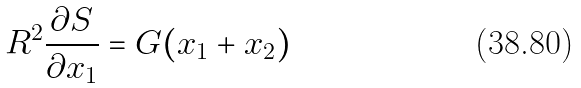Convert formula to latex. <formula><loc_0><loc_0><loc_500><loc_500>R ^ { 2 } \frac { \partial S } { \partial x _ { 1 } } = G ( x _ { 1 } + x _ { 2 } )</formula> 